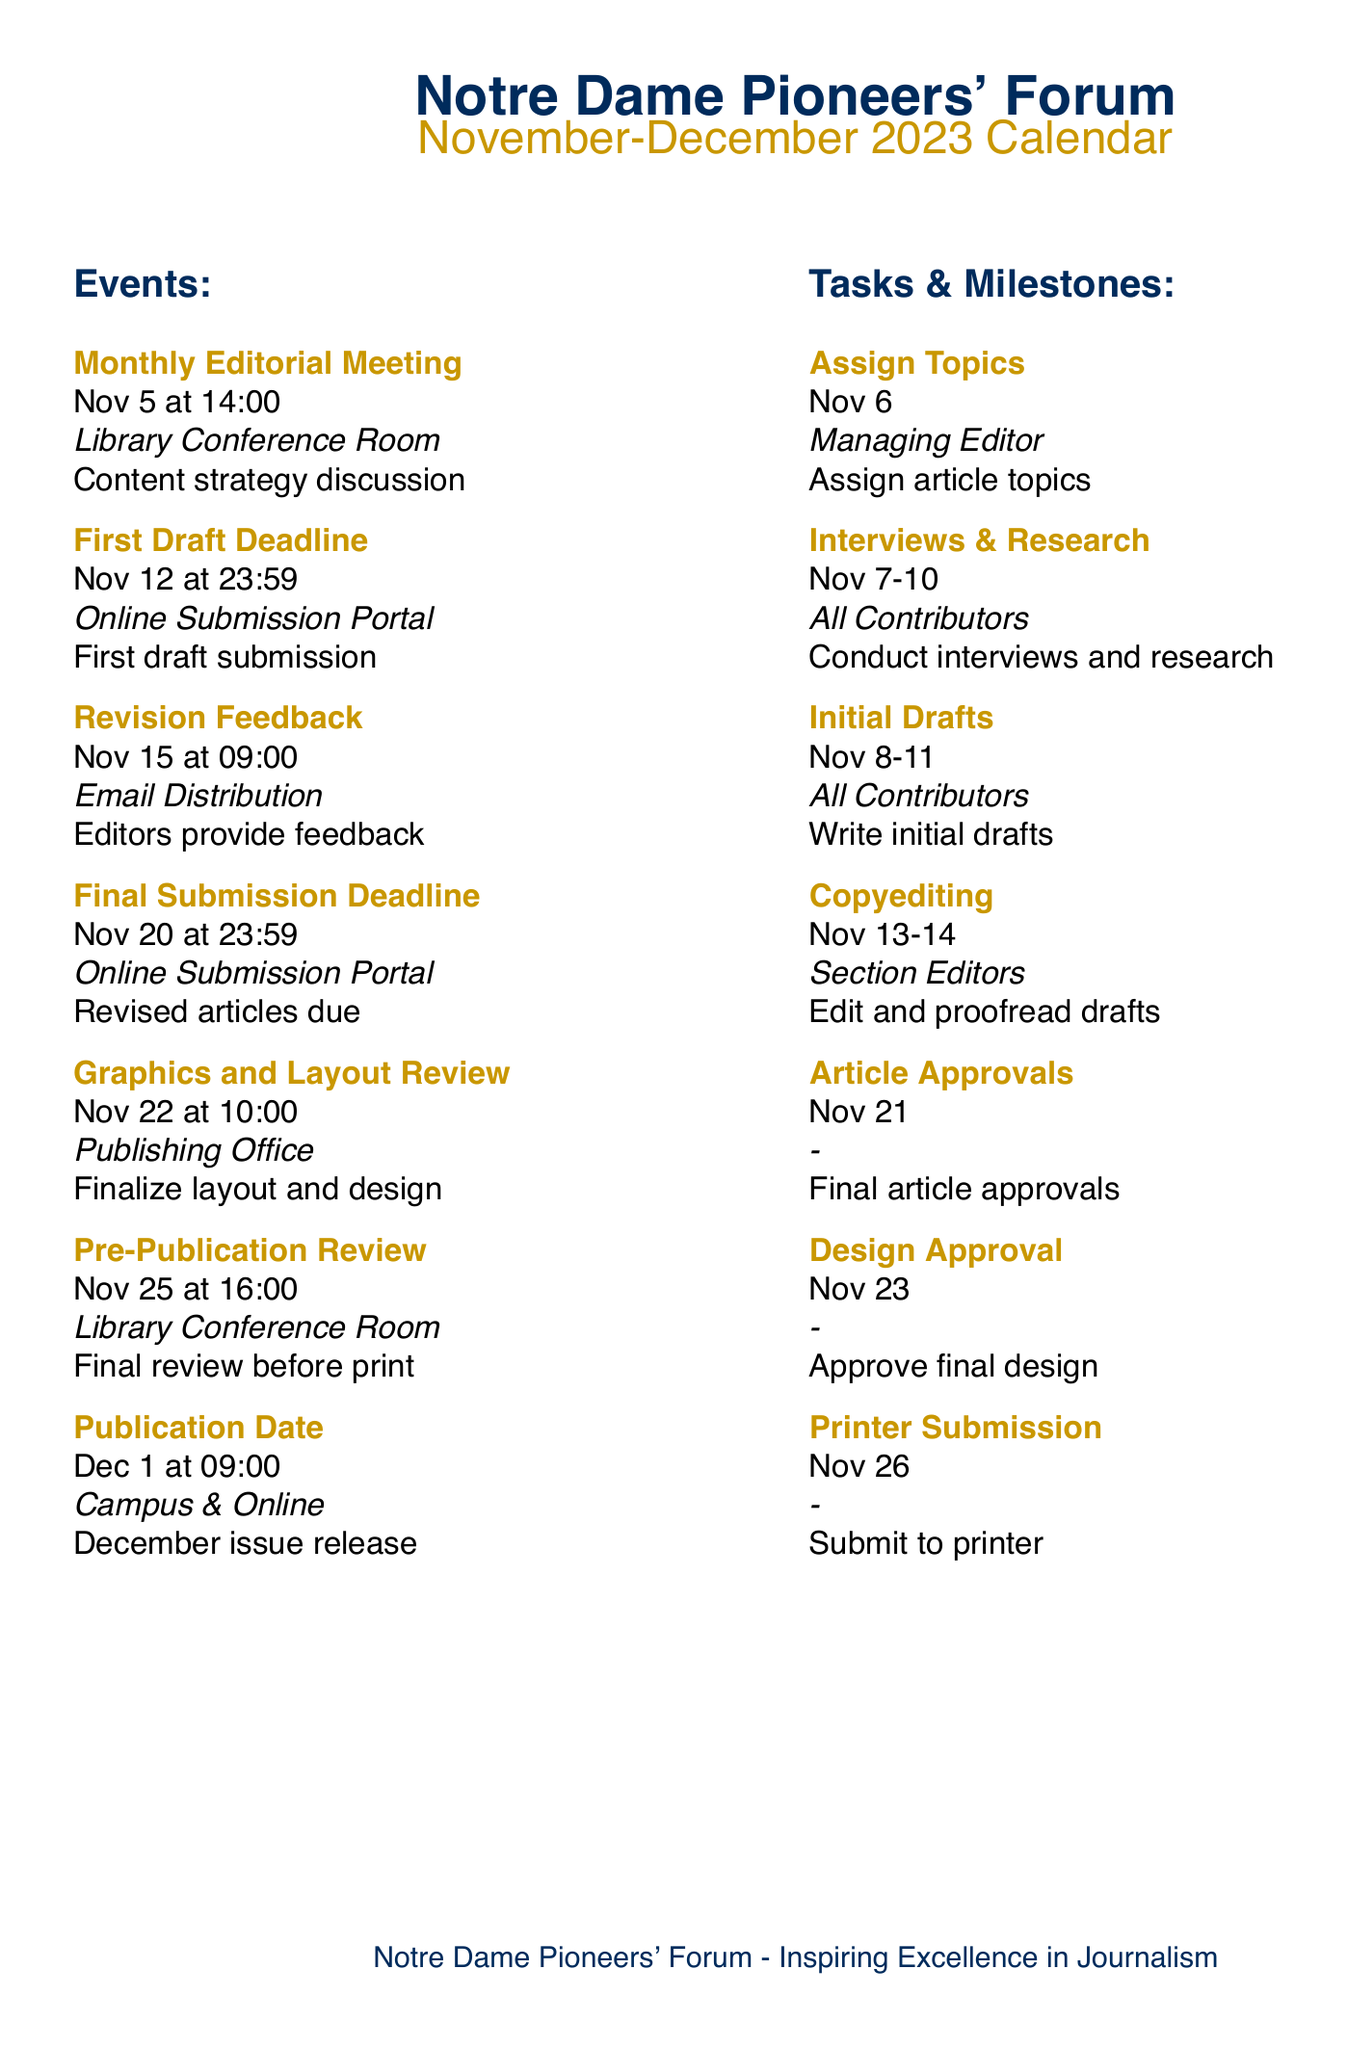What is the date of the Monthly Editorial Meeting? The date of the Monthly Editorial Meeting is specified in the document.
Answer: Nov 5 When is the First Draft Deadline? The First Draft Deadline is listed in the events section of the document.
Answer: Nov 12 Who is responsible for assigning topics? The person responsible for assigning topics is mentioned in the tasks section.
Answer: Managing Editor What event occurs on November 25? The document lists events occurring on specific dates, including this one.
Answer: Pre-Publication Review What time does the Graphics and Layout Review start? The time for the Graphics and Layout Review is provided in the events section.
Answer: 10:00 How many days are there between the Final Submission Deadline and the Publication Date? Calculating the days between the two provided dates gives the answer.
Answer: 11 days What is the task listed for November 13-14? The task scheduled for those dates is included in the tasks list.
Answer: Copyediting What is the final milestone before publication? The milestones are listed, and the last one before publication is specified.
Answer: Printer Submission 